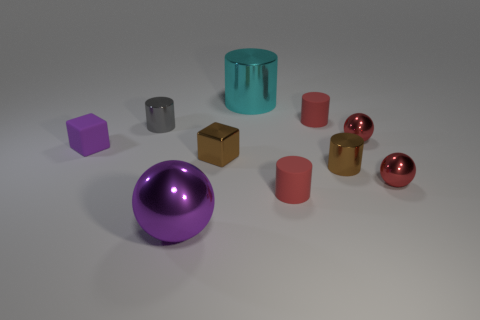Subtract 2 cylinders. How many cylinders are left? 3 Subtract all red cylinders. How many cylinders are left? 3 Subtract all gray cylinders. How many cylinders are left? 4 Subtract all cyan cylinders. Subtract all green blocks. How many cylinders are left? 4 Subtract all balls. How many objects are left? 7 Add 8 big cyan metal objects. How many big cyan metal objects are left? 9 Add 9 tiny matte blocks. How many tiny matte blocks exist? 10 Subtract 0 blue cubes. How many objects are left? 10 Subtract all small red cylinders. Subtract all gray cylinders. How many objects are left? 7 